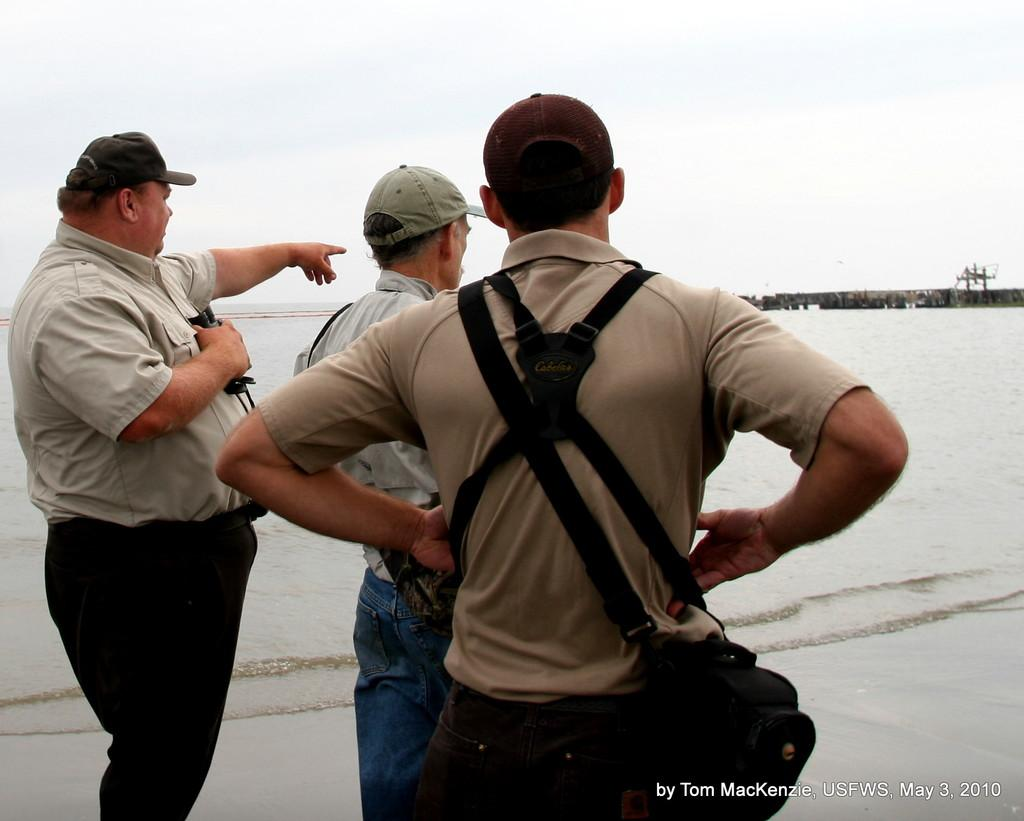What can be seen in the image? There are people standing in the image. What is the primary element visible in the image? There is water visible in the image. What type of trousers are the people wearing in the image? The provided facts do not mention the type of trousers the people are wearing, so it cannot be determined from the image. 